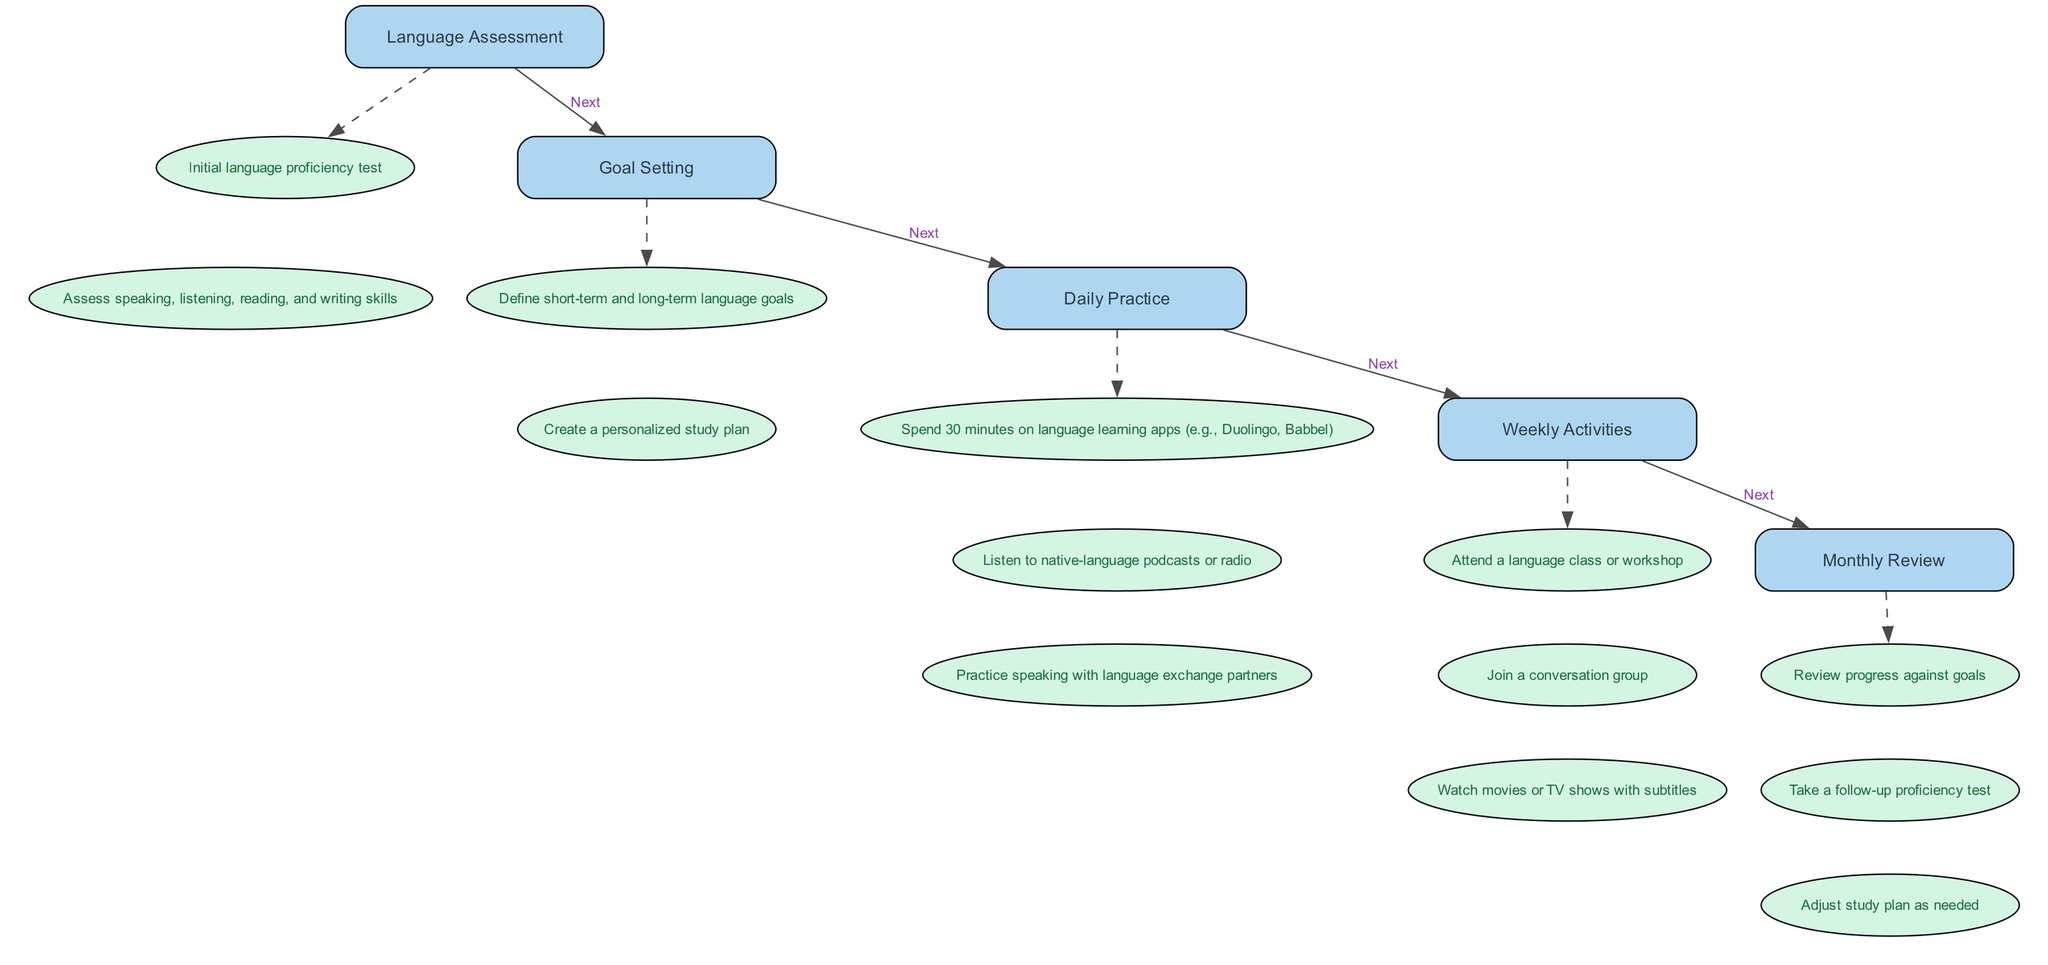What is the first step in the learning routine? The first step listed in the diagram is "Language Assessment". It is presented at the top of the flow and is the starting point before proceeding to the next steps.
Answer: Language Assessment How many activities are in the "Weekly Activities" step? In the "Weekly Activities" step, there are three activities listed: 1) Attend a language class or workshop, 2) Join a conversation group, and 3) Watch movies or TV shows with subtitles. Counting these gives a total of three activities.
Answer: 3 What step follows "Goal Setting"? The diagram shows the flow from one step to the next. After "Goal Setting", the next step indicated is "Daily Practice". Following the directed path, this is the immediate next step.
Answer: Daily Practice Which activity is related to speaking practice? Among the listed activities under "Daily Practice", "Practice speaking with language exchange partners" directly relates to speaking practice as it involves interaction and verbal communication in the language being learned.
Answer: Practice speaking with language exchange partners What do you do during the "Monthly Review"? The "Monthly Review" step contains three activities listed: 1) Review progress against goals, 2) Take a follow-up proficiency test, and 3) Adjust study plan as needed. All these activities involve reassessing and refining the learning process over the month.
Answer: Review progress against goals, take a follow-up proficiency test, adjust study plan as needed What connects the "Daily Practice" step to the "Weekly Activities" step? The diagram depicts a directed edge labeled "Next" that connects "Daily Practice" to "Weekly Activities", indicating that after completing daily practices, one should move on to the weekly activities.
Answer: Next Which step has an assessment activity involved? The "Monthly Review" step includes the activity "Take a follow-up proficiency test", which is specifically an assessment of progress in language learning. This indicates that assessments are part of ongoing evaluations.
Answer: Take a follow-up proficiency test What is the nature of the activities under each step? The activities under each step are structured as actionable tasks related to language learning, with "Language Assessment" focusing on evaluating skills, "Goal Setting" on planning, and so forth. This categorization provides clarity in the learning pathway.
Answer: Actionable tasks related to language learning How many nodes represent the main steps in the diagram? There are five main steps in the diagram: Language Assessment, Goal Setting, Daily Practice, Weekly Activities, and Monthly Review. Each step is represented as a node which can be clearly counted.
Answer: 5 